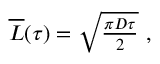<formula> <loc_0><loc_0><loc_500><loc_500>\begin{array} { r } { \overline { L } ( \tau ) = \sqrt { \frac { \pi D \tau } { 2 } } \ , } \end{array}</formula> 